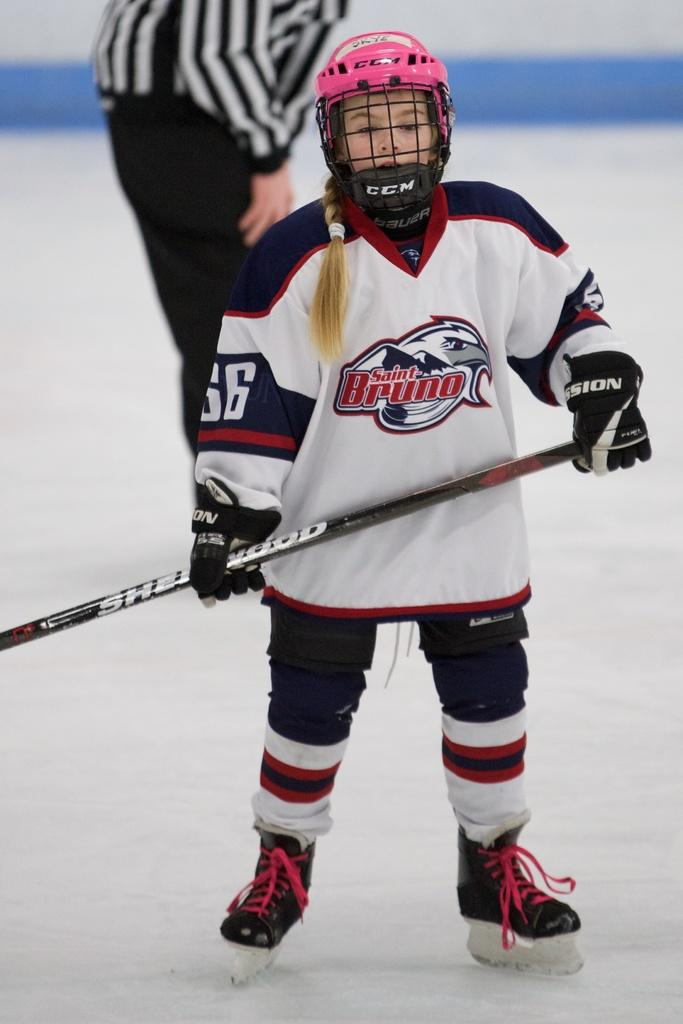What is present in the image? There is a person in the image. Can you describe the person's appearance? The person is wearing clothes. What is the person holding in the image? The person is holding a stick with her hands. Are there any other people in the image? Yes, there is another person in the image. Where is the other person located in the image? The other person is at the top of the image. What type of education is the person receiving from the stick in the image? There is no indication in the image that the person is receiving any education from the stick. 